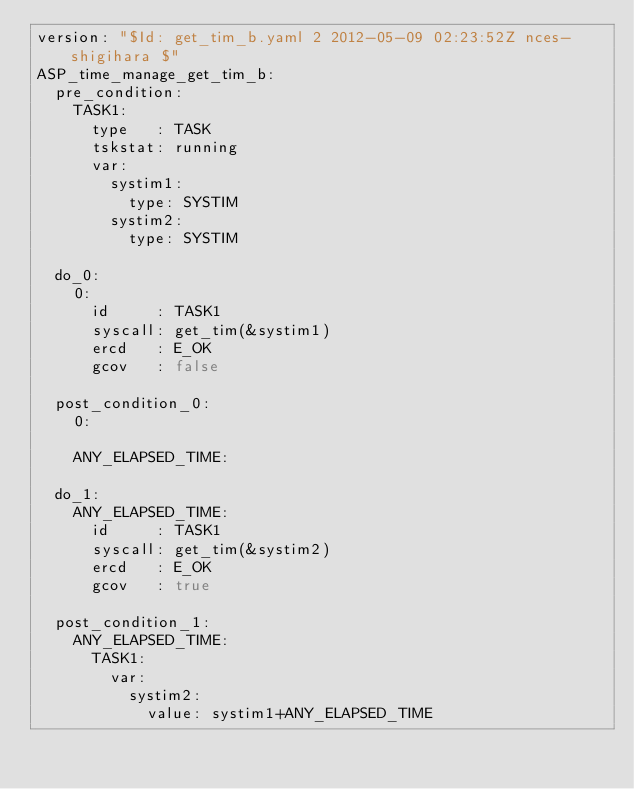Convert code to text. <code><loc_0><loc_0><loc_500><loc_500><_YAML_>version: "$Id: get_tim_b.yaml 2 2012-05-09 02:23:52Z nces-shigihara $"
ASP_time_manage_get_tim_b:
  pre_condition:
    TASK1:
      type   : TASK
      tskstat: running
      var:
        systim1:
          type: SYSTIM
        systim2:
          type: SYSTIM

  do_0:
    0:
      id     : TASK1
      syscall: get_tim(&systim1)
      ercd   : E_OK
      gcov   : false

  post_condition_0:
    0:

    ANY_ELAPSED_TIME:

  do_1:
    ANY_ELAPSED_TIME:
      id     : TASK1
      syscall: get_tim(&systim2)
      ercd   : E_OK
      gcov   : true

  post_condition_1:
    ANY_ELAPSED_TIME:
      TASK1:
        var:
          systim2:
            value: systim1+ANY_ELAPSED_TIME
</code> 